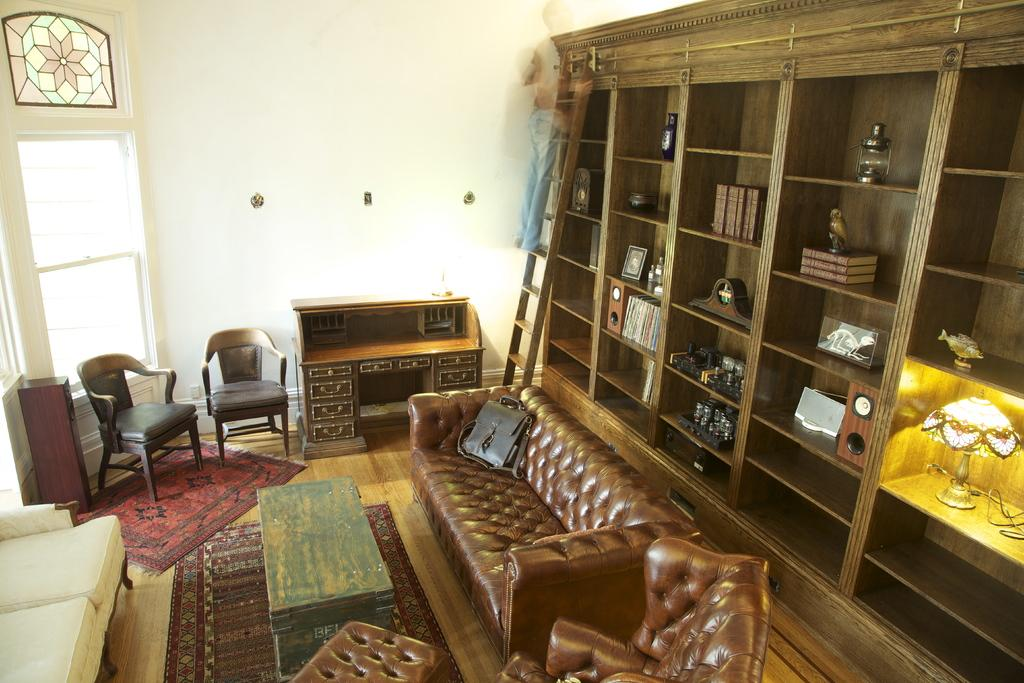What type of furniture is in the room? There is a sofa, chairs, and a table in the room. What is placed on the sofa? There is a bag on the sofa. What is used for climbing or reaching high places in the room? There is a ladder in the room. What is used for storing and displaying books in the room? There are racks with books in the room. What is used for providing light in the room? There are lamps in the room. What is used for displaying photos in the room? There are photo frames in the room. What is a part of the room's structure? There is a wall in the room. What is a source of natural light in the room? There is a window in the room. Can you see the ocean from the window in the room? There is no ocean visible from the window in the room; the window provides a view of the room's surroundings, not the ocean. 